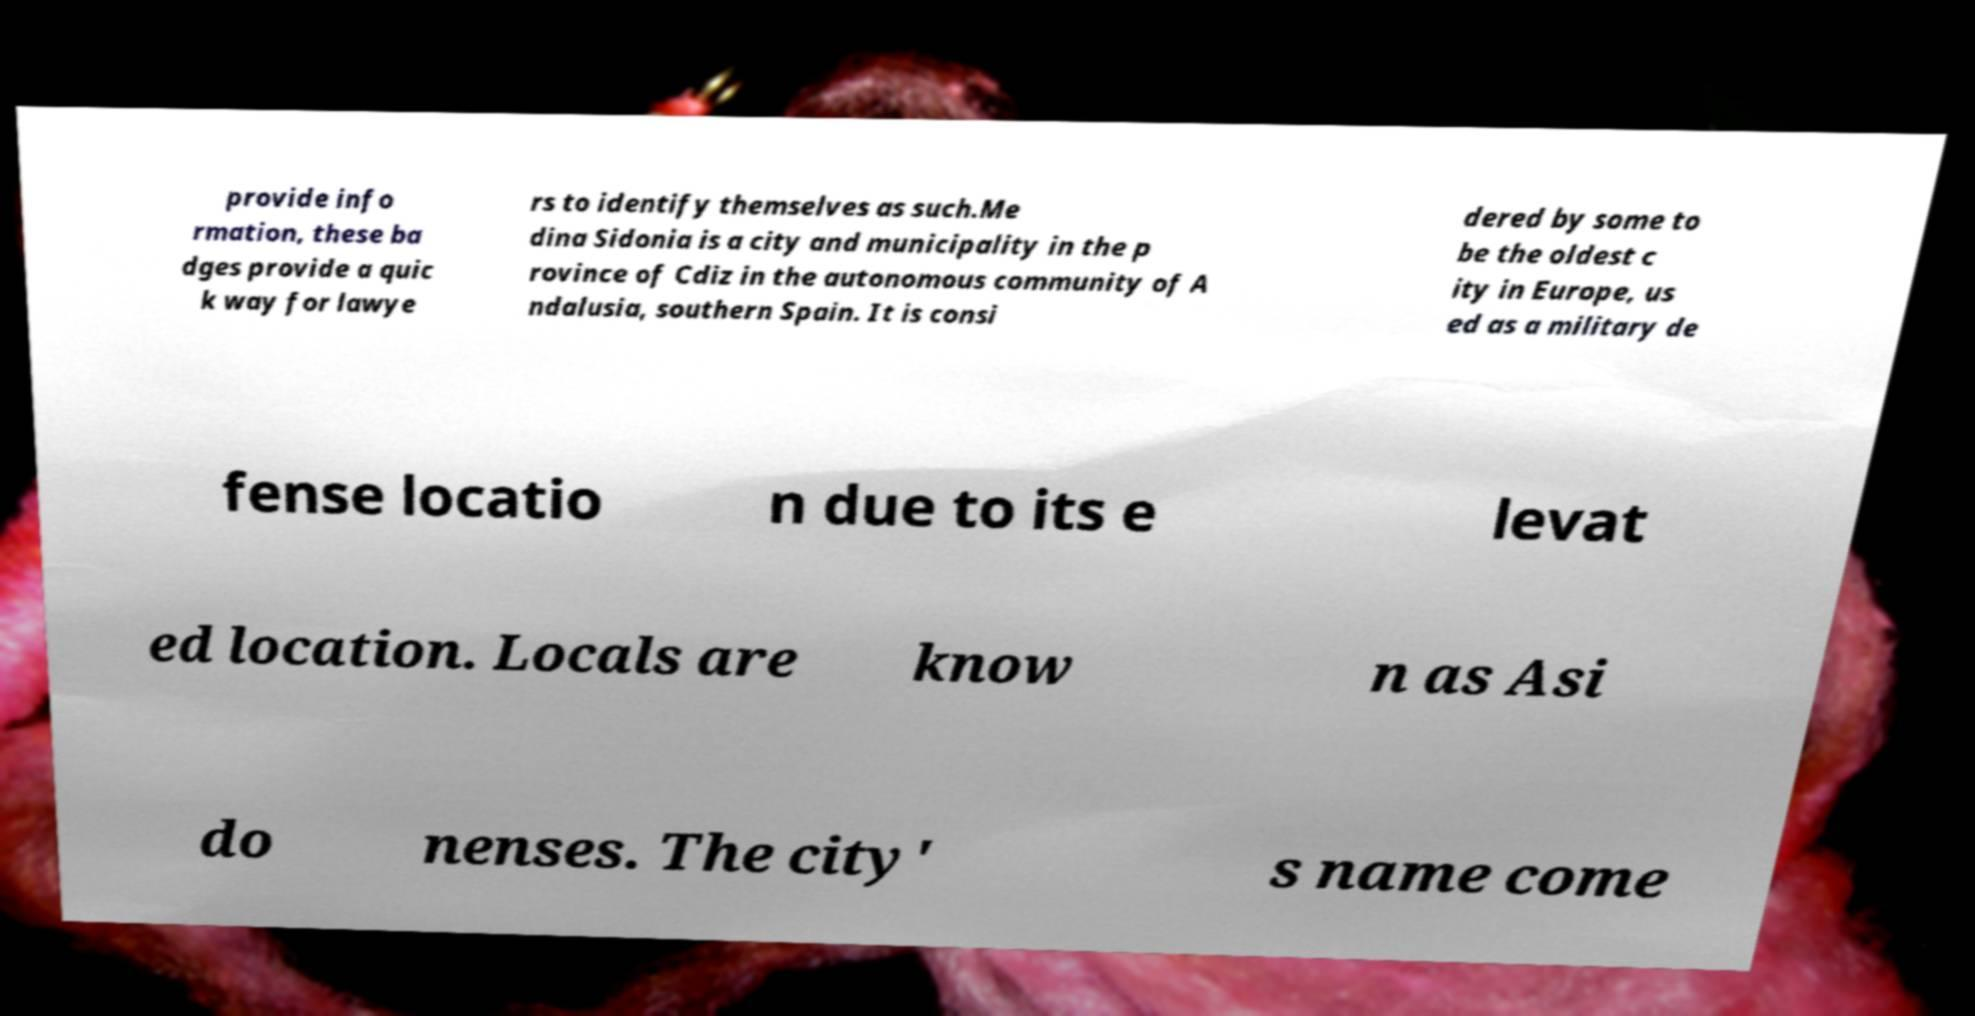Can you accurately transcribe the text from the provided image for me? provide info rmation, these ba dges provide a quic k way for lawye rs to identify themselves as such.Me dina Sidonia is a city and municipality in the p rovince of Cdiz in the autonomous community of A ndalusia, southern Spain. It is consi dered by some to be the oldest c ity in Europe, us ed as a military de fense locatio n due to its e levat ed location. Locals are know n as Asi do nenses. The city' s name come 